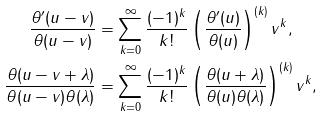Convert formula to latex. <formula><loc_0><loc_0><loc_500><loc_500>\frac { \theta ^ { \prime } ( u - v ) } { \theta ( u - v ) } & = \sum _ { k = 0 } ^ { \infty } \frac { ( - 1 ) ^ { k } } { k ! } \left ( \frac { \theta ^ { \prime } ( u ) } { \theta ( u ) } \right ) ^ { ( k ) } v ^ { k } , \\ \frac { \theta ( u - v + \lambda ) } { \theta ( u - v ) \theta ( \lambda ) } & = \sum _ { k = 0 } ^ { \infty } \frac { ( - 1 ) ^ { k } } { k ! } \left ( \frac { \theta ( u + \lambda ) } { \theta ( u ) \theta ( \lambda ) } \right ) ^ { ( k ) } v ^ { k } ,</formula> 